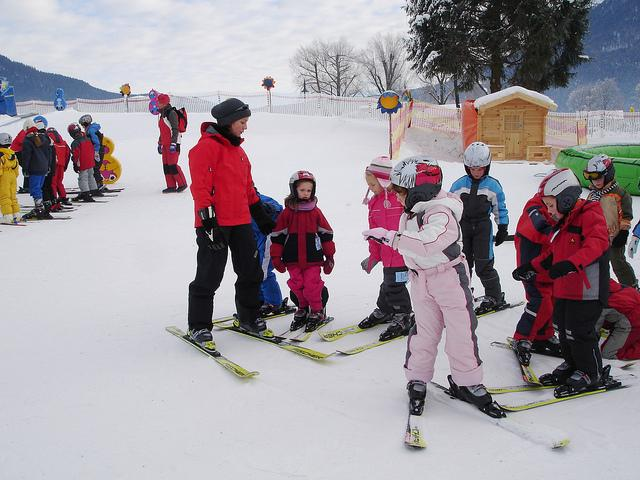Different parabolic shapes are found in? snow 